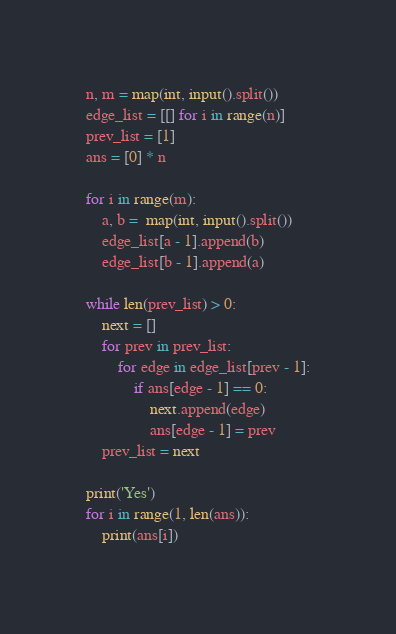Convert code to text. <code><loc_0><loc_0><loc_500><loc_500><_Python_>n, m = map(int, input().split())
edge_list = [[] for i in range(n)]
prev_list = [1]
ans = [0] * n

for i in range(m):
    a, b =  map(int, input().split())
    edge_list[a - 1].append(b)
    edge_list[b - 1].append(a)

while len(prev_list) > 0:
    next = []
    for prev in prev_list:
        for edge in edge_list[prev - 1]:
            if ans[edge - 1] == 0:
                next.append(edge)
                ans[edge - 1] = prev
    prev_list = next

print('Yes')
for i in range(1, len(ans)):
    print(ans[i])
</code> 